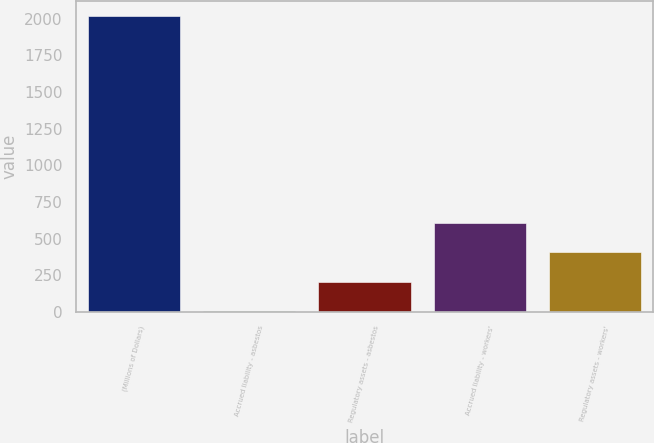Convert chart. <chart><loc_0><loc_0><loc_500><loc_500><bar_chart><fcel>(Millions of Dollars)<fcel>Accrued liability - asbestos<fcel>Regulatory assets - asbestos<fcel>Accrued liability - workers'<fcel>Regulatory assets - workers'<nl><fcel>2016<fcel>7<fcel>207.9<fcel>609.7<fcel>408.8<nl></chart> 